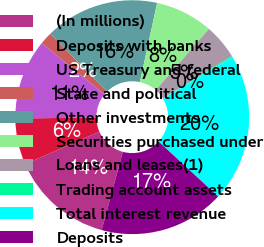<chart> <loc_0><loc_0><loc_500><loc_500><pie_chart><fcel>(In millions)<fcel>Deposits with banks<fcel>US Treasury and federal<fcel>State and political<fcel>Other investments<fcel>Securities purchased under<fcel>Loans and leases(1)<fcel>Trading account assets<fcel>Total interest revenue<fcel>Deposits<nl><fcel>14.21%<fcel>6.41%<fcel>11.09%<fcel>1.73%<fcel>15.78%<fcel>7.97%<fcel>4.85%<fcel>0.17%<fcel>20.46%<fcel>17.34%<nl></chart> 